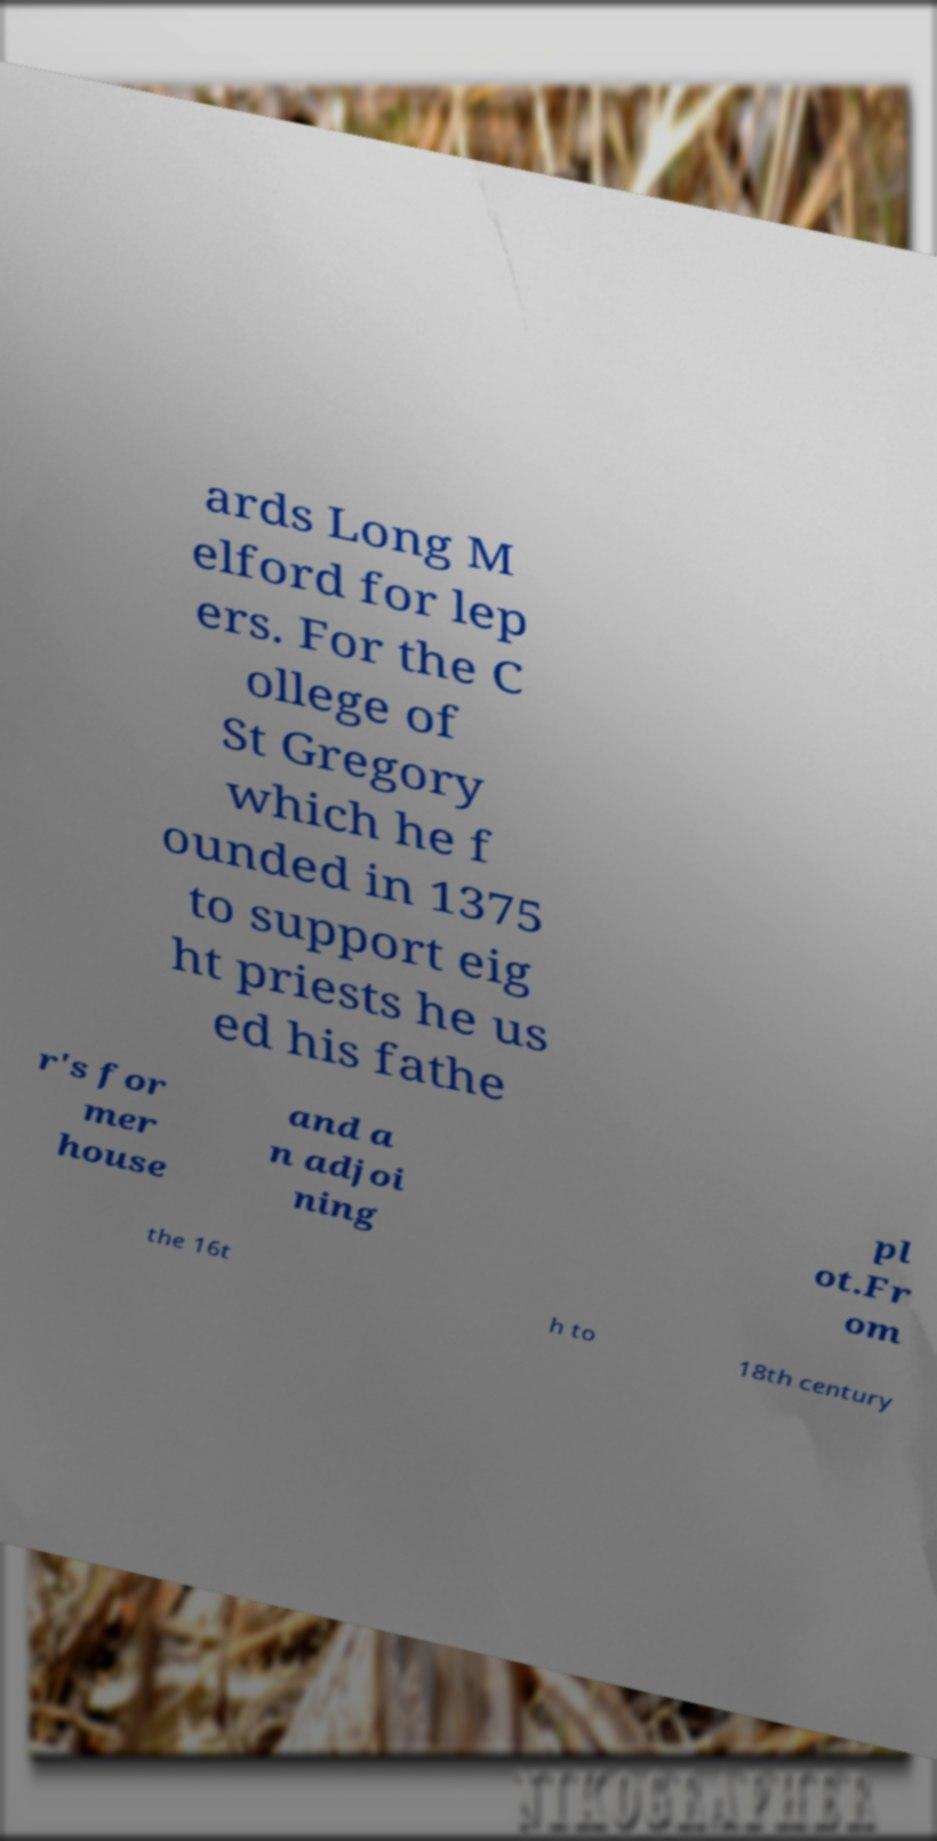What messages or text are displayed in this image? I need them in a readable, typed format. ards Long M elford for lep ers. For the C ollege of St Gregory which he f ounded in 1375 to support eig ht priests he us ed his fathe r's for mer house and a n adjoi ning pl ot.Fr om the 16t h to 18th century 